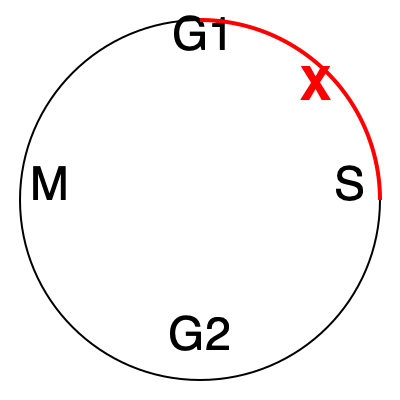In the cell cycle diagram above, the red arc represents the phase targeted by Dr. Henderson's cancer treatment. Which stage of the cell cycle does this correspond to, and why might it be an effective target for cancer therapy? 1. The diagram shows the four main stages of the cell cycle: G1, S, G2, and M.

2. The red arc covers the area labeled "S", which stands for the Synthesis phase.

3. During the S phase:
   - DNA replication occurs
   - The cell's genetic material is doubled

4. Cancer cells often divide more rapidly than normal cells, making them more vulnerable during DNA replication.

5. Targeting the S phase can be effective because:
   - It disrupts DNA synthesis in rapidly dividing cancer cells
   - Many chemotherapy drugs work by interfering with DNA replication
   - Damaging DNA during this phase can lead to cell death or prevent further division

6. By focusing on this phase, Dr. Henderson's treatment likely aims to selectively harm cancer cells while minimizing damage to normal cells that divide less frequently.
Answer: S phase (DNA synthesis); targets rapid cell division in cancer 